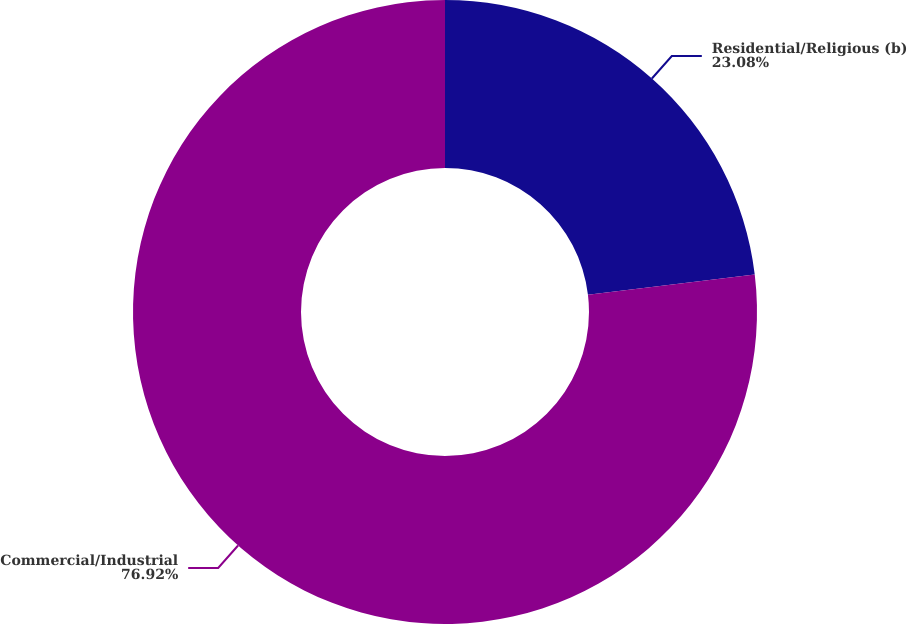<chart> <loc_0><loc_0><loc_500><loc_500><pie_chart><fcel>Residential/Religious (b)<fcel>Commercial/Industrial<nl><fcel>23.08%<fcel>76.92%<nl></chart> 